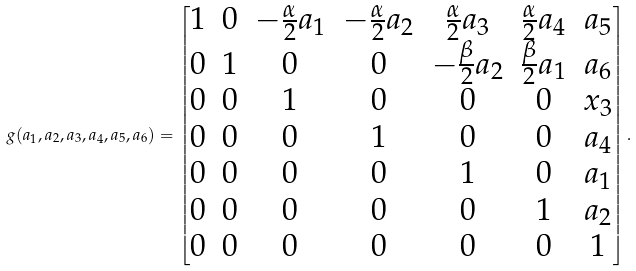<formula> <loc_0><loc_0><loc_500><loc_500>g ( a _ { 1 } , a _ { 2 } , a _ { 3 } , a _ { 4 } , a _ { 5 } , a _ { 6 } ) = \begin{bmatrix} 1 & 0 & - \frac { \alpha } { 2 } a _ { 1 } & - \frac { \alpha } { 2 } a _ { 2 } & \frac { \alpha } { 2 } a _ { 3 } & \frac { \alpha } { 2 } a _ { 4 } & a _ { 5 } \\ 0 & 1 & 0 & 0 & - \frac { \beta } { 2 } a _ { 2 } & \frac { \beta } { 2 } a _ { 1 } & a _ { 6 } \\ 0 & 0 & 1 & 0 & 0 & 0 & x _ { 3 } \\ 0 & 0 & 0 & 1 & 0 & 0 & a _ { 4 } \\ 0 & 0 & 0 & 0 & 1 & 0 & a _ { 1 } \\ 0 & 0 & 0 & 0 & 0 & 1 & a _ { 2 } \\ 0 & 0 & 0 & 0 & 0 & 0 & 1 \end{bmatrix} .</formula> 